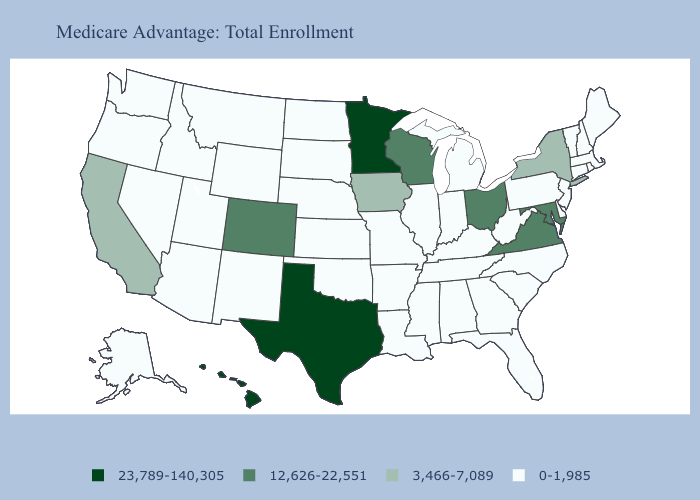Does Washington have the same value as Mississippi?
Quick response, please. Yes. Among the states that border Arizona , does California have the highest value?
Quick response, please. No. Which states hav the highest value in the Northeast?
Give a very brief answer. New York. What is the value of New Mexico?
Write a very short answer. 0-1,985. Which states have the highest value in the USA?
Answer briefly. Hawaii, Minnesota, Texas. Does the map have missing data?
Answer briefly. No. Which states have the lowest value in the Northeast?
Quick response, please. Connecticut, Massachusetts, Maine, New Hampshire, New Jersey, Pennsylvania, Rhode Island, Vermont. What is the highest value in the Northeast ?
Give a very brief answer. 3,466-7,089. Does Hawaii have the highest value in the USA?
Write a very short answer. Yes. What is the lowest value in the USA?
Give a very brief answer. 0-1,985. What is the value of Wisconsin?
Keep it brief. 12,626-22,551. Among the states that border Oregon , does California have the lowest value?
Concise answer only. No. Among the states that border Wisconsin , does Illinois have the highest value?
Concise answer only. No. Name the states that have a value in the range 3,466-7,089?
Quick response, please. California, Iowa, New York. What is the value of Rhode Island?
Give a very brief answer. 0-1,985. 